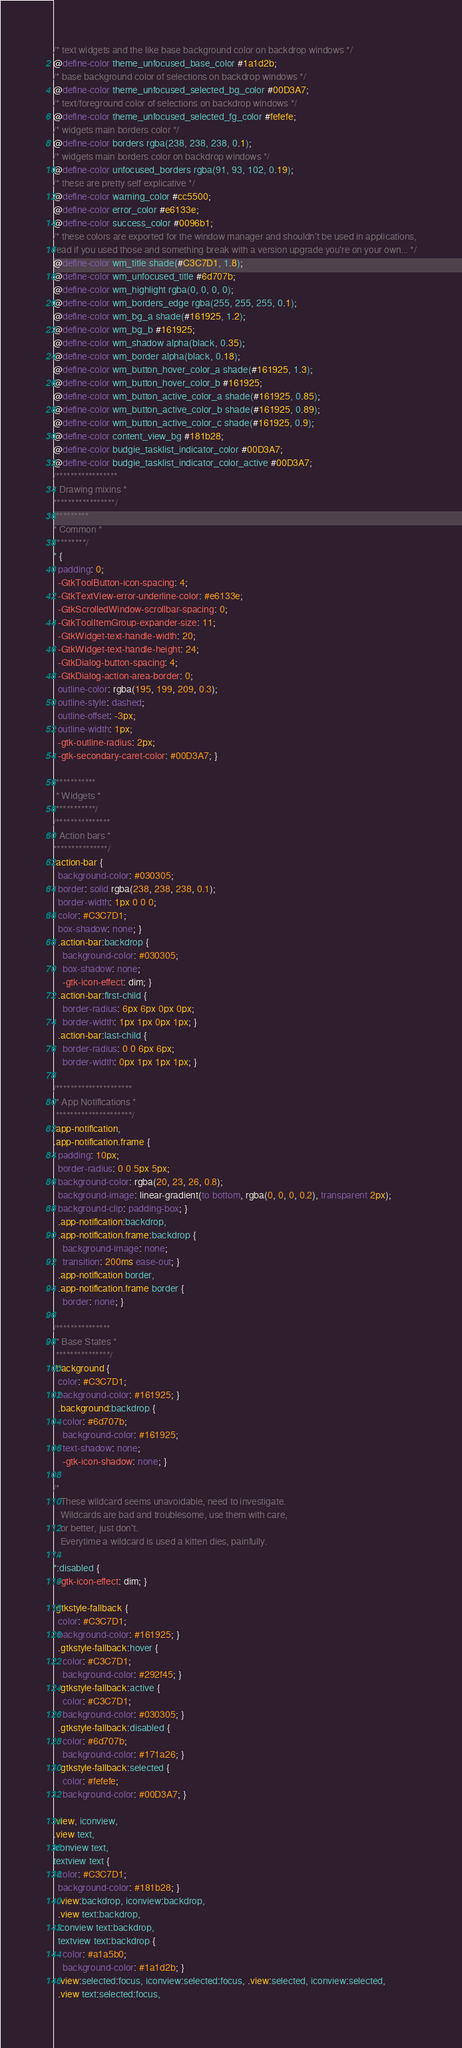Convert code to text. <code><loc_0><loc_0><loc_500><loc_500><_CSS_>/* text widgets and the like base background color on backdrop windows */
@define-color theme_unfocused_base_color #1a1d2b;
/* base background color of selections on backdrop windows */
@define-color theme_unfocused_selected_bg_color #00D3A7;
/* text/foreground color of selections on backdrop windows */
@define-color theme_unfocused_selected_fg_color #fefefe;
/* widgets main borders color */
@define-color borders rgba(238, 238, 238, 0.1);
/* widgets main borders color on backdrop windows */
@define-color unfocused_borders rgba(91, 93, 102, 0.19);
/* these are pretty self explicative */
@define-color warning_color #cc5500;
@define-color error_color #e6133e;
@define-color success_color #0096b1;
/* these colors are exported for the window manager and shouldn't be used in applications,
read if you used those and something break with a version upgrade you're on your own... */
@define-color wm_title shade(#C3C7D1, 1.8);
@define-color wm_unfocused_title #6d707b;
@define-color wm_highlight rgba(0, 0, 0, 0);
@define-color wm_borders_edge rgba(255, 255, 255, 0.1);
@define-color wm_bg_a shade(#161925, 1.2);
@define-color wm_bg_b #161925;
@define-color wm_shadow alpha(black, 0.35);
@define-color wm_border alpha(black, 0.18);
@define-color wm_button_hover_color_a shade(#161925, 1.3);
@define-color wm_button_hover_color_b #161925;
@define-color wm_button_active_color_a shade(#161925, 0.85);
@define-color wm_button_active_color_b shade(#161925, 0.89);
@define-color wm_button_active_color_c shade(#161925, 0.9);
@define-color content_view_bg #181b28;
@define-color budgie_tasklist_indicator_color #00D3A7;
@define-color budgie_tasklist_indicator_color_active #00D3A7;
/*****************
* Drawing mixins *
*****************/
/*********
* Common *
*********/
* {
  padding: 0;
  -GtkToolButton-icon-spacing: 4;
  -GtkTextView-error-underline-color: #e6133e;
  -GtkScrolledWindow-scrollbar-spacing: 0;
  -GtkToolItemGroup-expander-size: 11;
  -GtkWidget-text-handle-width: 20;
  -GtkWidget-text-handle-height: 24;
  -GtkDialog-button-spacing: 4;
  -GtkDialog-action-area-border: 0;
  outline-color: rgba(195, 199, 209, 0.3);
  outline-style: dashed;
  outline-offset: -3px;
  outline-width: 1px;
  -gtk-outline-radius: 2px;
  -gtk-secondary-caret-color: #00D3A7; }

/***********
 * Widgets *
 ***********/
/***************
* Action bars *
***************/
.action-bar {
  background-color: #030305;
  border: solid rgba(238, 238, 238, 0.1);
  border-width: 1px 0 0 0;
  color: #C3C7D1;
  box-shadow: none; }
  .action-bar:backdrop {
    background-color: #030305;
    box-shadow: none;
    -gtk-icon-effect: dim; }
  .action-bar:first-child {
    border-radius: 6px 6px 0px 0px;
    border-width: 1px 1px 0px 1px; }
  .action-bar:last-child {
    border-radius: 0 0 6px 6px;
    border-width: 0px 1px 1px 1px; }

/*********************
 * App Notifications *
 *********************/
.app-notification,
.app-notification.frame {
  padding: 10px;
  border-radius: 0 0 5px 5px;
  background-color: rgba(20, 23, 26, 0.8);
  background-image: linear-gradient(to bottom, rgba(0, 0, 0, 0.2), transparent 2px);
  background-clip: padding-box; }
  .app-notification:backdrop,
  .app-notification.frame:backdrop {
    background-image: none;
    transition: 200ms ease-out; }
  .app-notification border,
  .app-notification.frame border {
    border: none; }

/***************
 * Base States *
 ***************/
.background {
  color: #C3C7D1;
  background-color: #161925; }
  .background:backdrop {
    color: #6d707b;
    background-color: #161925;
    text-shadow: none;
    -gtk-icon-shadow: none; }

/*
   These wildcard seems unavoidable, need to investigate.
   Wildcards are bad and troublesome, use them with care,
   or better, just don't.
   Everytime a wildcard is used a kitten dies, painfully.
*/
*:disabled {
  -gtk-icon-effect: dim; }

.gtkstyle-fallback {
  color: #C3C7D1;
  background-color: #161925; }
  .gtkstyle-fallback:hover {
    color: #C3C7D1;
    background-color: #292f45; }
  .gtkstyle-fallback:active {
    color: #C3C7D1;
    background-color: #030305; }
  .gtkstyle-fallback:disabled {
    color: #6d707b;
    background-color: #171a26; }
  .gtkstyle-fallback:selected {
    color: #fefefe;
    background-color: #00D3A7; }

.view, iconview,
.view text,
iconview text,
textview text {
  color: #C3C7D1;
  background-color: #181b28; }
  .view:backdrop, iconview:backdrop,
  .view text:backdrop,
  iconview text:backdrop,
  textview text:backdrop {
    color: #a1a5b0;
    background-color: #1a1d2b; }
  .view:selected:focus, iconview:selected:focus, .view:selected, iconview:selected,
  .view text:selected:focus,</code> 